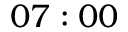Convert formula to latex. <formula><loc_0><loc_0><loc_500><loc_500>0 7 \colon 0 0</formula> 